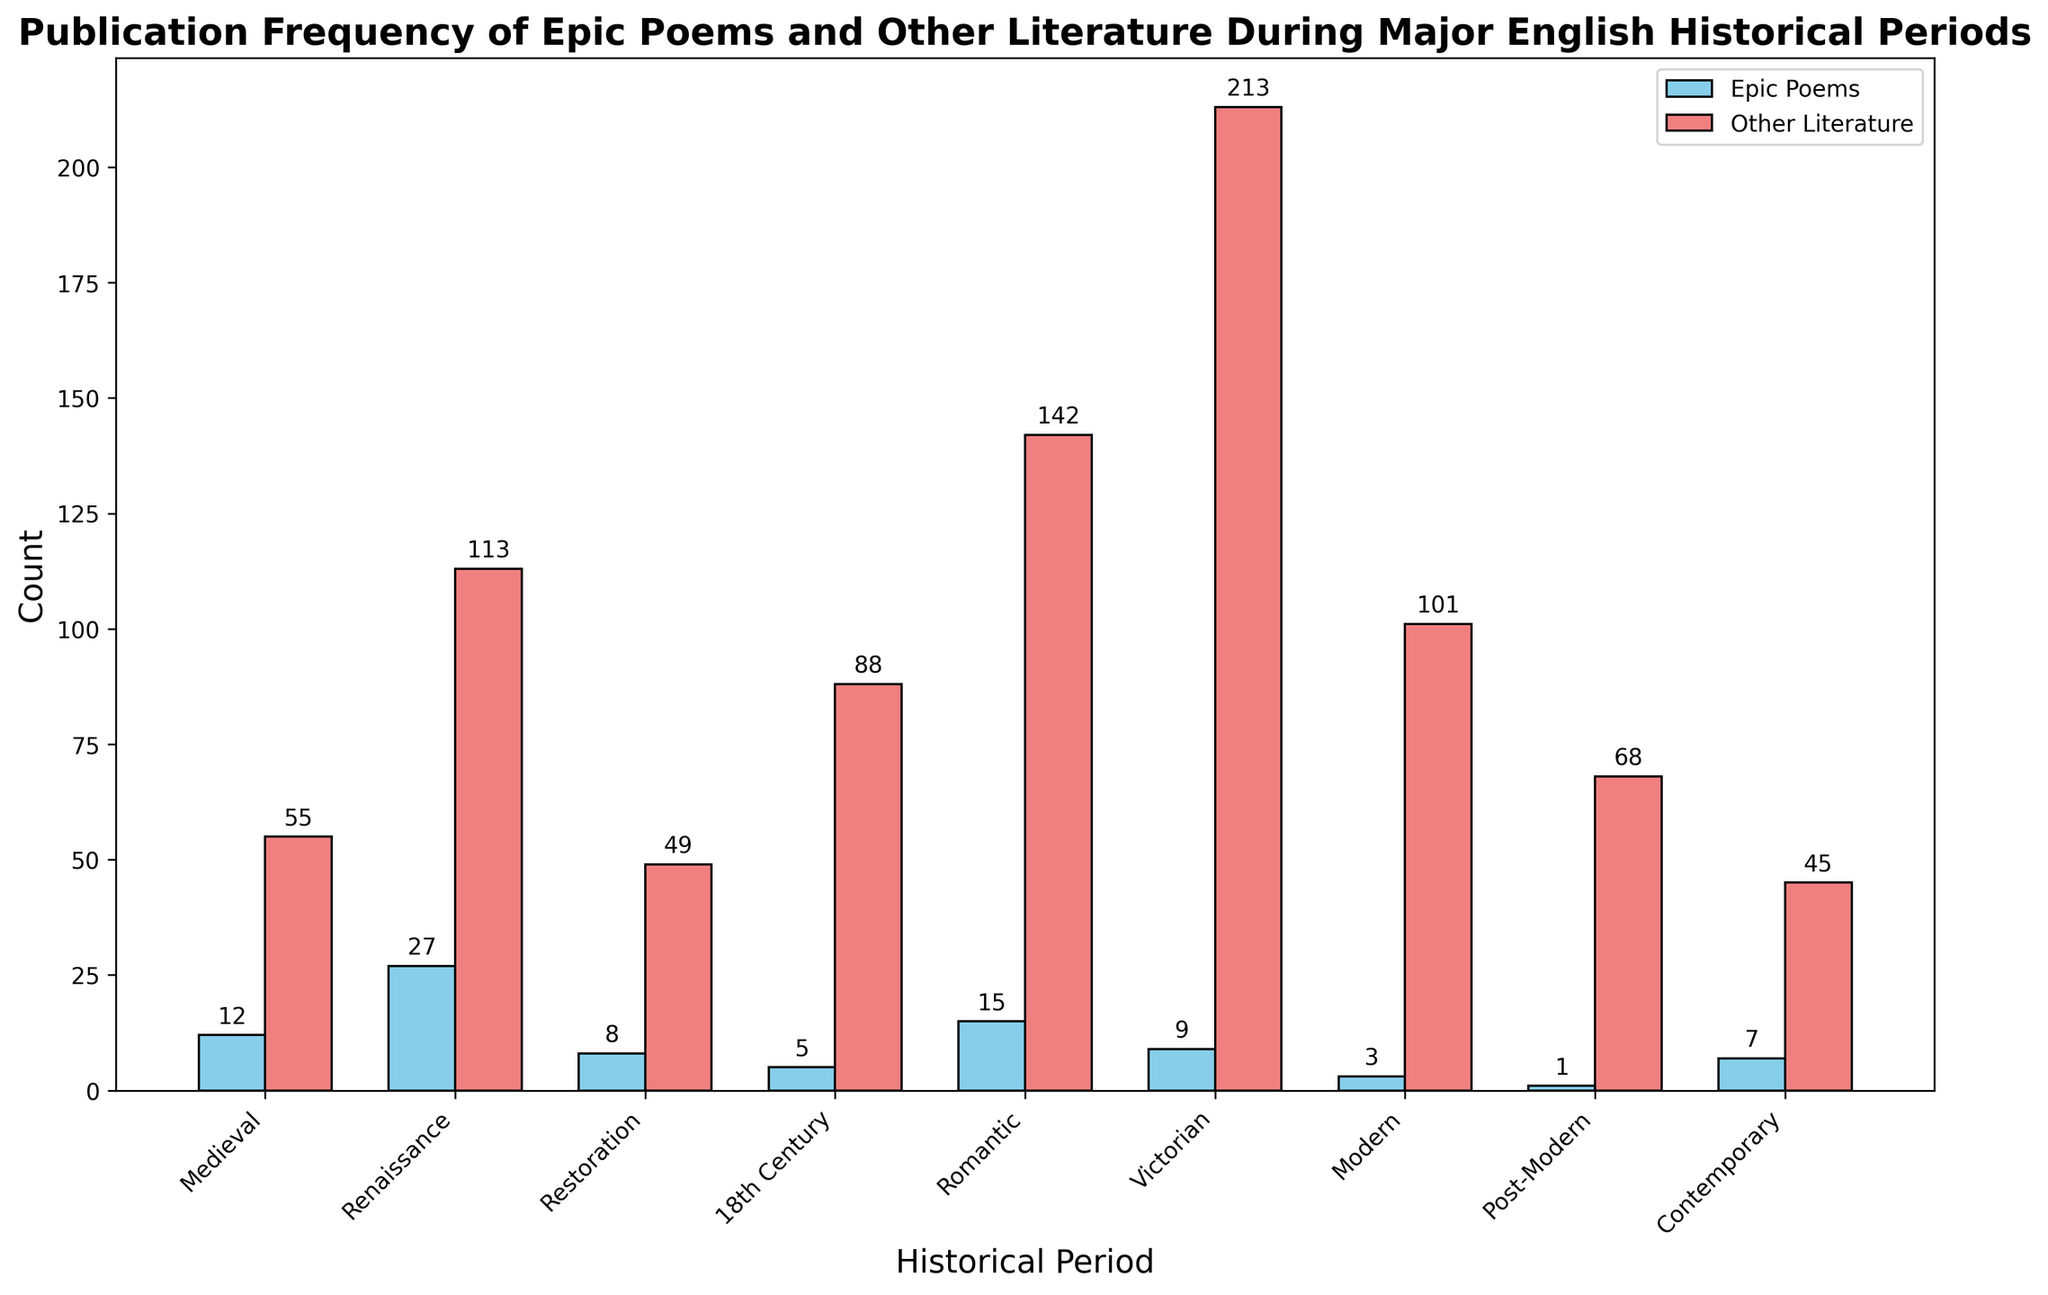What's the historical period with the highest publication frequency of epic poems? To find the historical period with the highest publication frequency of epic poems, look for the tallest bar representing epic poems. In the plot, the Renaissance period has the tallest blue bar among the bars for epic poems.
Answer: Renaissance How many more epic poems were published during the Renaissance compared to the Victorian period? Check the heights of the blue bars (epic poems) for both the Renaissance and Victorian periods. The counts are 27 for the Renaissance and 9 for the Victorian. Calculate the difference: 27 - 9 = 18.
Answer: 18 During which periods were less than 10 epic poems published? Identify the blue bars (epic poems) with heights less than 10. The periods are Restoration (8), 18th Century (5), Victorian (9), Modern (3), Post-Modern (1), and Contemporary (7).
Answer: Restoration, 18th Century, Victorian, Modern, Post-Modern, Contemporary What is the total number of publications (epic poems and other literature) during the Medieval period? Sum the counts of both categories for the Medieval period. The counts are 12 for epic poems and 55 for other literature. Add them together: 12 + 55 = 67.
Answer: 67 Compare the counts of epic poems and other literature during the Romantic period. Which had more, and by how much? Check the heights of the blue bar and the red bar for the Romantic period. The counts are 15 for epic poems and 142 for other literature. Calculate the difference: 142 - 15 = 127. Other literature had more.
Answer: Other literature, 127 Which historical period has the smallest difference in publication counts between epic poems and other literature? Calculate the difference between the counts of epic poems and other literature for each period. The smallest difference will be the lowest value among these differences. The differences are:
- Medieval: 55 - 12 = 43
- Renaissance: 113 - 27 = 86
- Restoration: 49 - 8 = 41
- 18th Century: 88 - 5 = 83
- Romantic: 142 - 15 = 127
- Victorian: 213 - 9 = 204
- Modern: 101 - 3 = 98
- Post-Modern: 68 - 1 = 67
- Contemporary: 45 - 7 = 38
The smallest difference is 38 during the Contemporary period.
Answer: Contemporary What is the ratio of epic poems to other literature publications during the Medieval period? Divide the count of epic poems by the count of other literature for the Medieval period. The counts are 12 for epic poems and 55 for other literature. The ratio is 12/55.
Answer: 12/55 Between which two consecutive periods is there the largest decrease in the count of epic poems? Compare the counts of epic poems between each pair of consecutive periods and identify where the largest decrease occurs. The decreases between periods are:
- Medieval to Renaissance: 27 - 12 = 15 (increase)
- Renaissance to Restoration: 27 - 8 = 19 (decrease)
- Restoration to 18th Century: 8 - 5 = 3 (decrease)
- 18th Century to Romantic: 15 - 5 = 10 (increase)
- Romantic to Victorian: 15 - 9 = 6 (decrease)
- Victorian to Modern: 9 - 3 = 6 (decrease)
- Modern to Post-Modern: 3 - 1 = 2 (decrease)
- Post-Modern to Contemporary: 7 - 1 = 6 (increase)
The largest decrease is from Renaissance to Restoration with a decrease of 19.
Answer: Renaissance to Restoration 